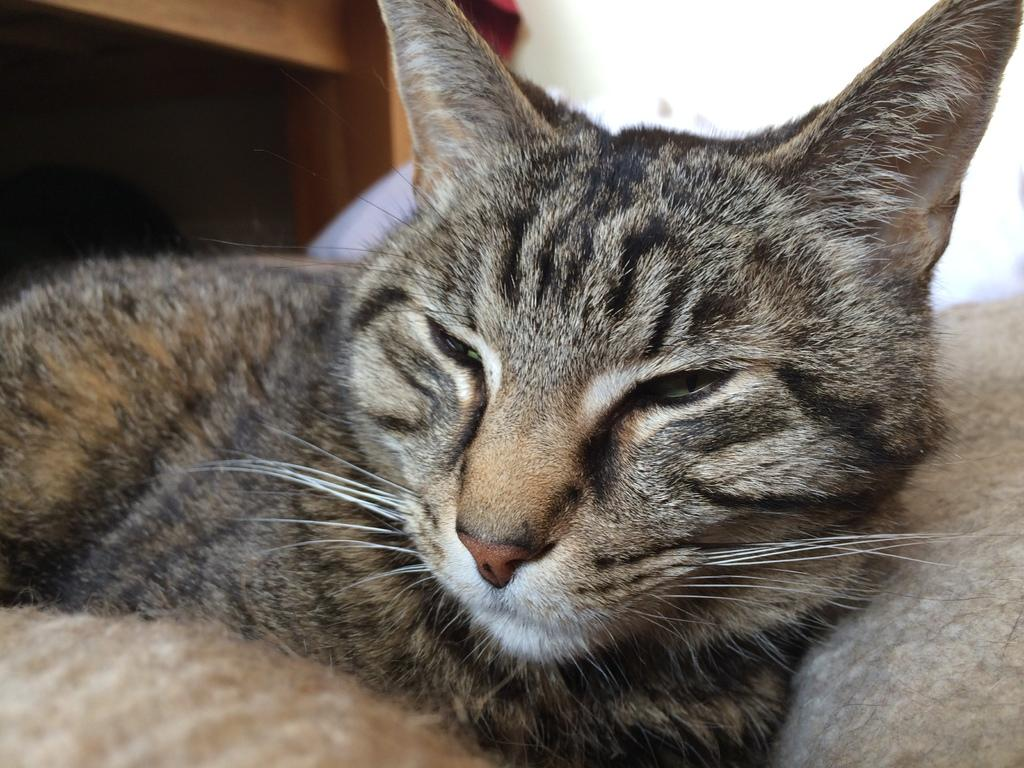What type of animal is in the image? There is a cat in the image. Where is the cat located? The cat is on a surface. What can be seen in the background of the image? There is a tablecloth and a wall in the background of the image. What type of brass instrument is the cat playing in the image? There is no brass instrument present in the image; it features a cat on a surface with a tablecloth and a wall in the background. 